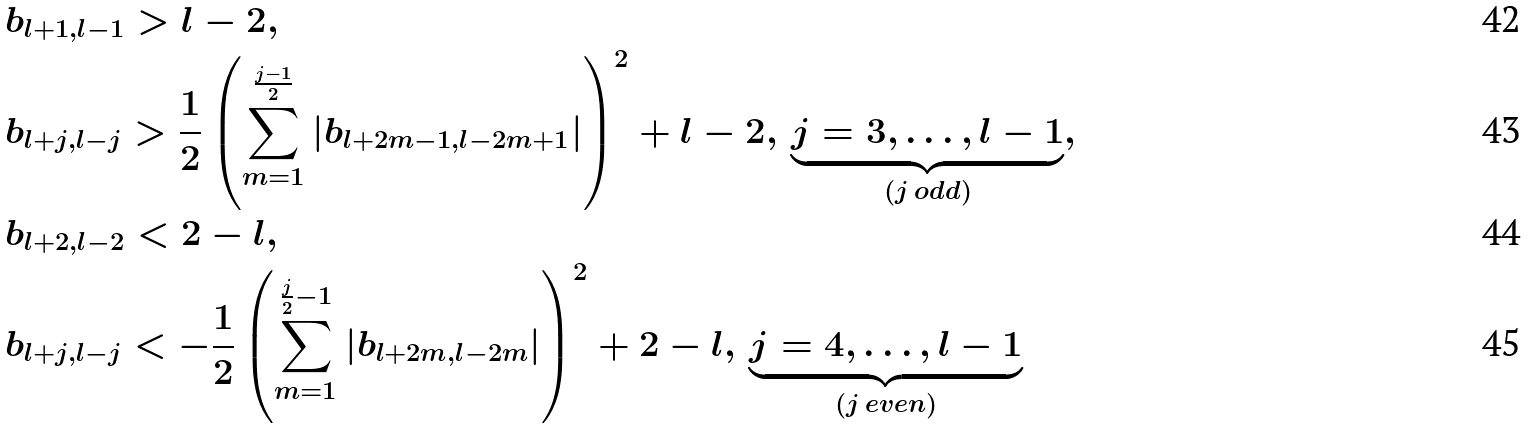Convert formula to latex. <formula><loc_0><loc_0><loc_500><loc_500>& b _ { l + 1 , l - 1 } > l - 2 , \\ & b _ { l + j , l - j } > \frac { 1 } { 2 } \left ( \sum _ { m = 1 } ^ { \frac { j - 1 } { 2 } } | b _ { l + 2 m - 1 , l - 2 m + 1 } | \right ) ^ { 2 } + l - 2 , \, \underbrace { j = 3 , \dots , l - 1 } _ { ( j \, o d d ) } , \\ & b _ { l + 2 , l - 2 } < 2 - l , \\ & b _ { l + j , l - j } < - \frac { 1 } { 2 } \left ( \sum _ { m = 1 } ^ { \frac { j } { 2 } - 1 } | b _ { l + 2 m , l - 2 m } | \right ) ^ { 2 } + 2 - l , \, \underbrace { j = 4 , \dots , l - 1 } _ { ( j \, e v e n ) }</formula> 